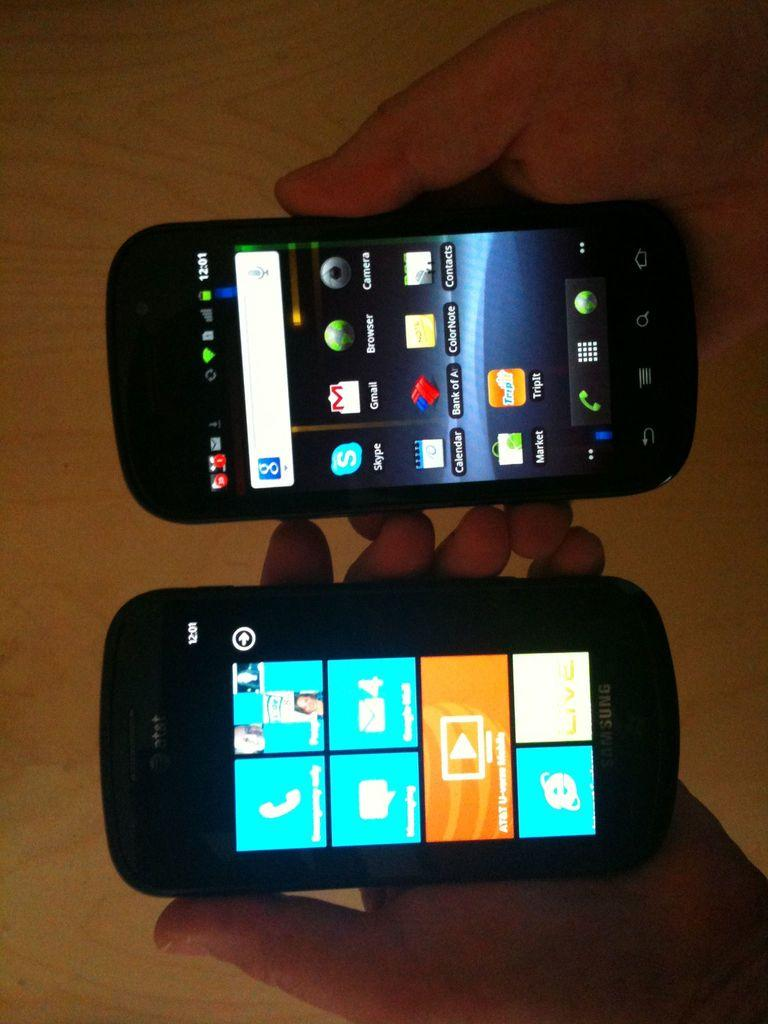<image>
Share a concise interpretation of the image provided. A person holds two cell phones in their hands and they both show the same time. 